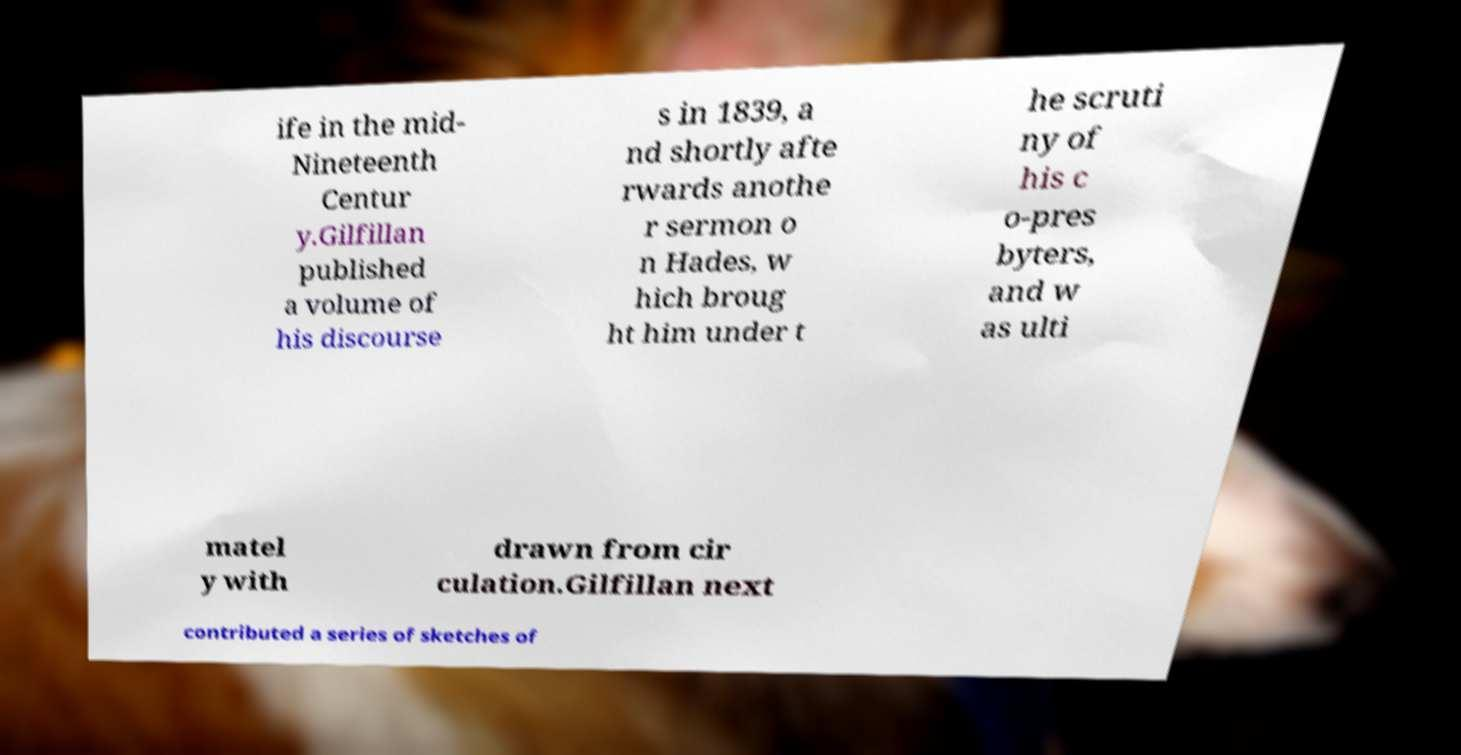Please read and relay the text visible in this image. What does it say? ife in the mid- Nineteenth Centur y.Gilfillan published a volume of his discourse s in 1839, a nd shortly afte rwards anothe r sermon o n Hades, w hich broug ht him under t he scruti ny of his c o-pres byters, and w as ulti matel y with drawn from cir culation.Gilfillan next contributed a series of sketches of 